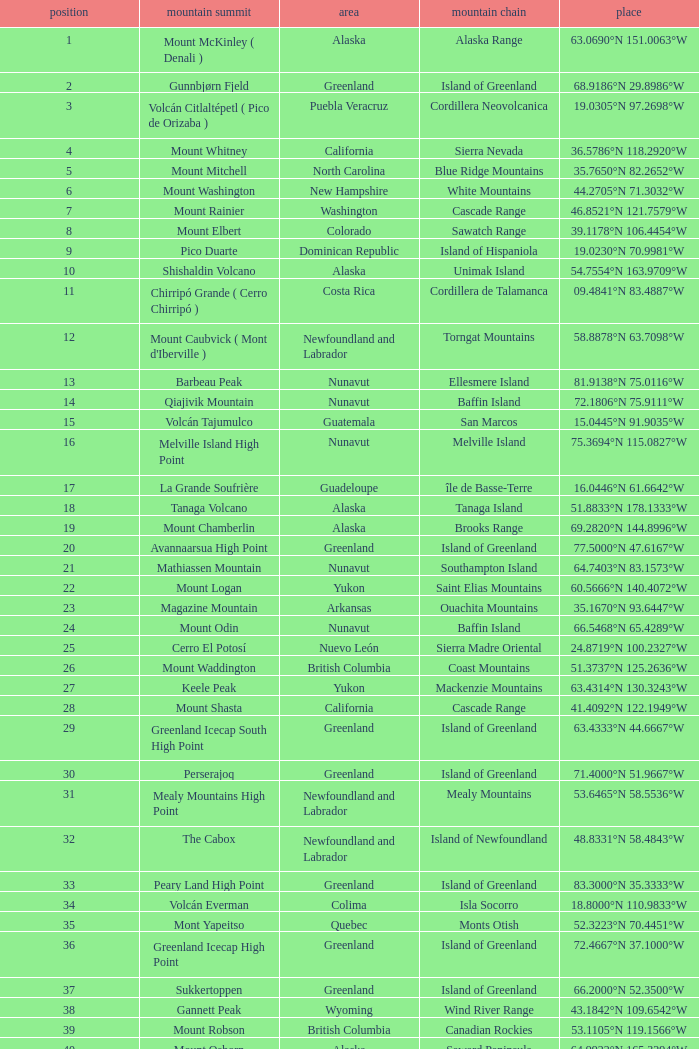Which Mountain Peak has a Region of baja california, and a Location of 28.1301°n 115.2206°w? Isla Cedros High Point. 